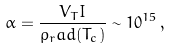Convert formula to latex. <formula><loc_0><loc_0><loc_500><loc_500>\alpha = \frac { V _ { T } I } { \rho _ { r } a d ( T _ { c } ) } \sim 1 0 ^ { 1 5 } \, ,</formula> 